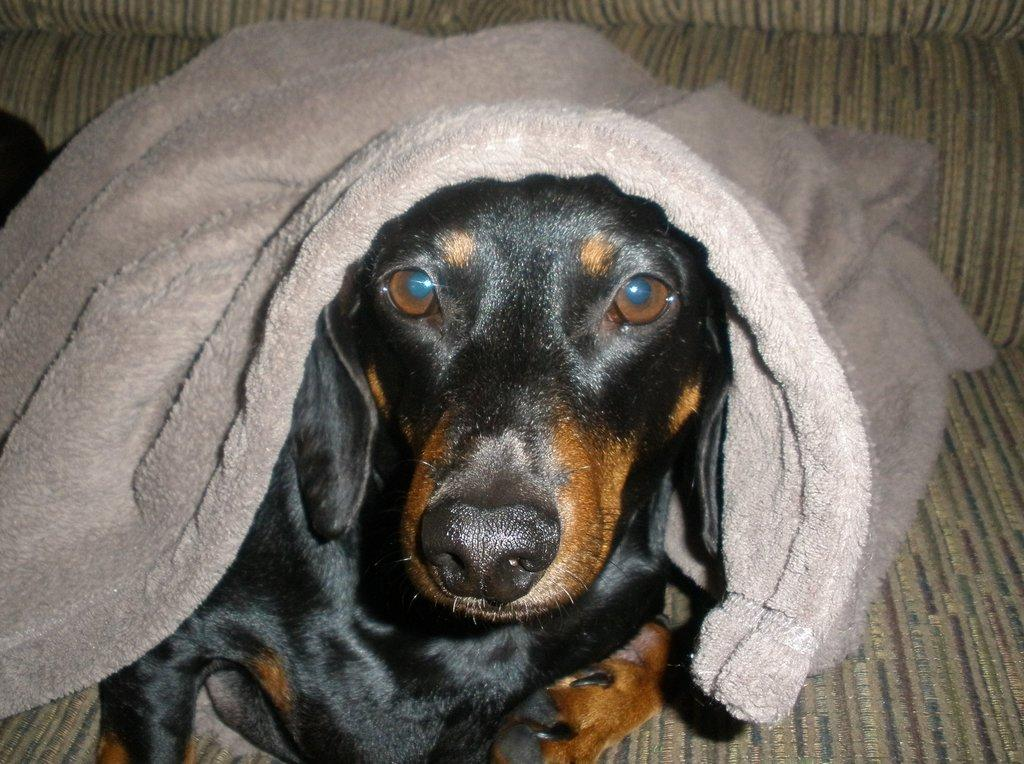What type of animal is in the image? There is a dog in the image. What colors can be seen on the dog's fur? The dog has black and brown coloring. Is there anything covering the dog in the image? Yes, there is a grey cloth on the dog. What type of vacation is the dog planning in the image? There is no indication in the image that the dog is planning a vacation, as dogs do not plan vacations. 